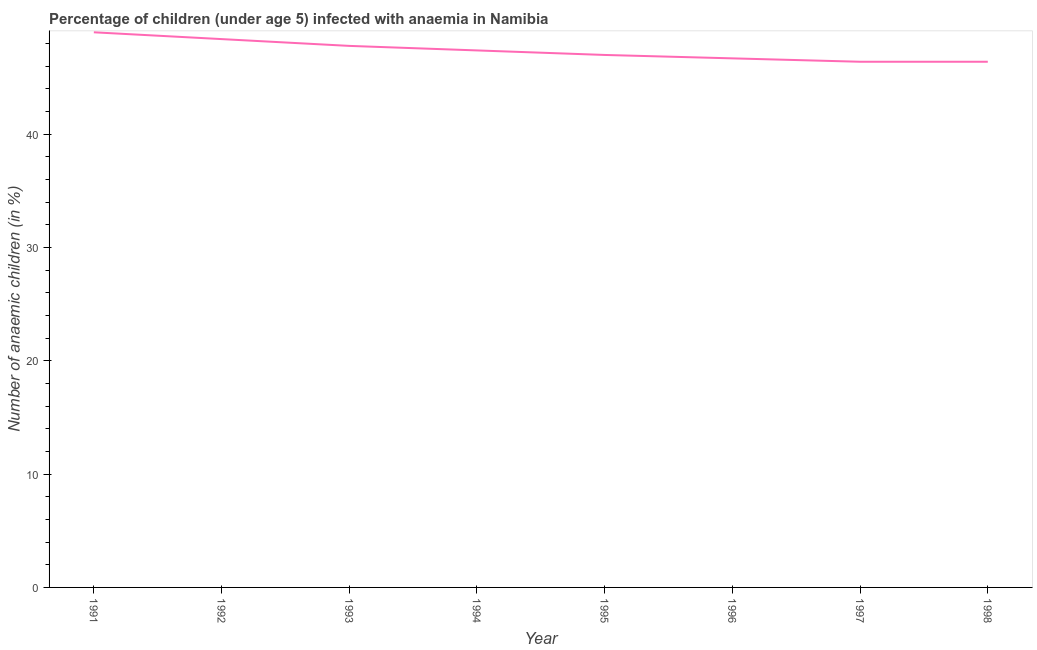What is the number of anaemic children in 1994?
Ensure brevity in your answer.  47.4. Across all years, what is the minimum number of anaemic children?
Provide a short and direct response. 46.4. In which year was the number of anaemic children minimum?
Make the answer very short. 1997. What is the sum of the number of anaemic children?
Make the answer very short. 379.1. What is the difference between the number of anaemic children in 1991 and 1997?
Your response must be concise. 2.6. What is the average number of anaemic children per year?
Keep it short and to the point. 47.39. What is the median number of anaemic children?
Your answer should be compact. 47.2. What is the ratio of the number of anaemic children in 1992 to that in 1993?
Ensure brevity in your answer.  1.01. Is the difference between the number of anaemic children in 1996 and 1997 greater than the difference between any two years?
Your response must be concise. No. What is the difference between the highest and the second highest number of anaemic children?
Give a very brief answer. 0.6. What is the difference between the highest and the lowest number of anaemic children?
Keep it short and to the point. 2.6. Does the number of anaemic children monotonically increase over the years?
Ensure brevity in your answer.  No. How many lines are there?
Keep it short and to the point. 1. What is the difference between two consecutive major ticks on the Y-axis?
Keep it short and to the point. 10. Are the values on the major ticks of Y-axis written in scientific E-notation?
Your answer should be very brief. No. Does the graph contain grids?
Keep it short and to the point. No. What is the title of the graph?
Keep it short and to the point. Percentage of children (under age 5) infected with anaemia in Namibia. What is the label or title of the X-axis?
Keep it short and to the point. Year. What is the label or title of the Y-axis?
Ensure brevity in your answer.  Number of anaemic children (in %). What is the Number of anaemic children (in %) in 1992?
Provide a succinct answer. 48.4. What is the Number of anaemic children (in %) in 1993?
Your answer should be compact. 47.8. What is the Number of anaemic children (in %) of 1994?
Your answer should be very brief. 47.4. What is the Number of anaemic children (in %) in 1995?
Keep it short and to the point. 47. What is the Number of anaemic children (in %) in 1996?
Your answer should be very brief. 46.7. What is the Number of anaemic children (in %) of 1997?
Your answer should be compact. 46.4. What is the Number of anaemic children (in %) in 1998?
Offer a terse response. 46.4. What is the difference between the Number of anaemic children (in %) in 1991 and 1992?
Ensure brevity in your answer.  0.6. What is the difference between the Number of anaemic children (in %) in 1991 and 1993?
Provide a short and direct response. 1.2. What is the difference between the Number of anaemic children (in %) in 1991 and 1994?
Your answer should be compact. 1.6. What is the difference between the Number of anaemic children (in %) in 1991 and 1997?
Your answer should be compact. 2.6. What is the difference between the Number of anaemic children (in %) in 1992 and 1993?
Keep it short and to the point. 0.6. What is the difference between the Number of anaemic children (in %) in 1992 and 1997?
Your answer should be compact. 2. What is the difference between the Number of anaemic children (in %) in 1993 and 1996?
Make the answer very short. 1.1. What is the difference between the Number of anaemic children (in %) in 1993 and 1998?
Your response must be concise. 1.4. What is the difference between the Number of anaemic children (in %) in 1994 and 1995?
Offer a terse response. 0.4. What is the difference between the Number of anaemic children (in %) in 1994 and 1997?
Provide a succinct answer. 1. What is the difference between the Number of anaemic children (in %) in 1995 and 1996?
Make the answer very short. 0.3. What is the difference between the Number of anaemic children (in %) in 1995 and 1997?
Provide a short and direct response. 0.6. What is the ratio of the Number of anaemic children (in %) in 1991 to that in 1992?
Offer a very short reply. 1.01. What is the ratio of the Number of anaemic children (in %) in 1991 to that in 1993?
Provide a short and direct response. 1.02. What is the ratio of the Number of anaemic children (in %) in 1991 to that in 1994?
Offer a very short reply. 1.03. What is the ratio of the Number of anaemic children (in %) in 1991 to that in 1995?
Offer a very short reply. 1.04. What is the ratio of the Number of anaemic children (in %) in 1991 to that in 1996?
Your response must be concise. 1.05. What is the ratio of the Number of anaemic children (in %) in 1991 to that in 1997?
Ensure brevity in your answer.  1.06. What is the ratio of the Number of anaemic children (in %) in 1991 to that in 1998?
Keep it short and to the point. 1.06. What is the ratio of the Number of anaemic children (in %) in 1992 to that in 1995?
Provide a short and direct response. 1.03. What is the ratio of the Number of anaemic children (in %) in 1992 to that in 1996?
Offer a terse response. 1.04. What is the ratio of the Number of anaemic children (in %) in 1992 to that in 1997?
Give a very brief answer. 1.04. What is the ratio of the Number of anaemic children (in %) in 1992 to that in 1998?
Offer a terse response. 1.04. What is the ratio of the Number of anaemic children (in %) in 1993 to that in 1994?
Provide a short and direct response. 1.01. What is the ratio of the Number of anaemic children (in %) in 1993 to that in 1996?
Your answer should be compact. 1.02. What is the ratio of the Number of anaemic children (in %) in 1993 to that in 1997?
Your answer should be compact. 1.03. What is the ratio of the Number of anaemic children (in %) in 1994 to that in 1996?
Your answer should be compact. 1.01. What is the ratio of the Number of anaemic children (in %) in 1994 to that in 1997?
Make the answer very short. 1.02. What is the ratio of the Number of anaemic children (in %) in 1995 to that in 1996?
Keep it short and to the point. 1.01. What is the ratio of the Number of anaemic children (in %) in 1996 to that in 1998?
Provide a short and direct response. 1.01. 